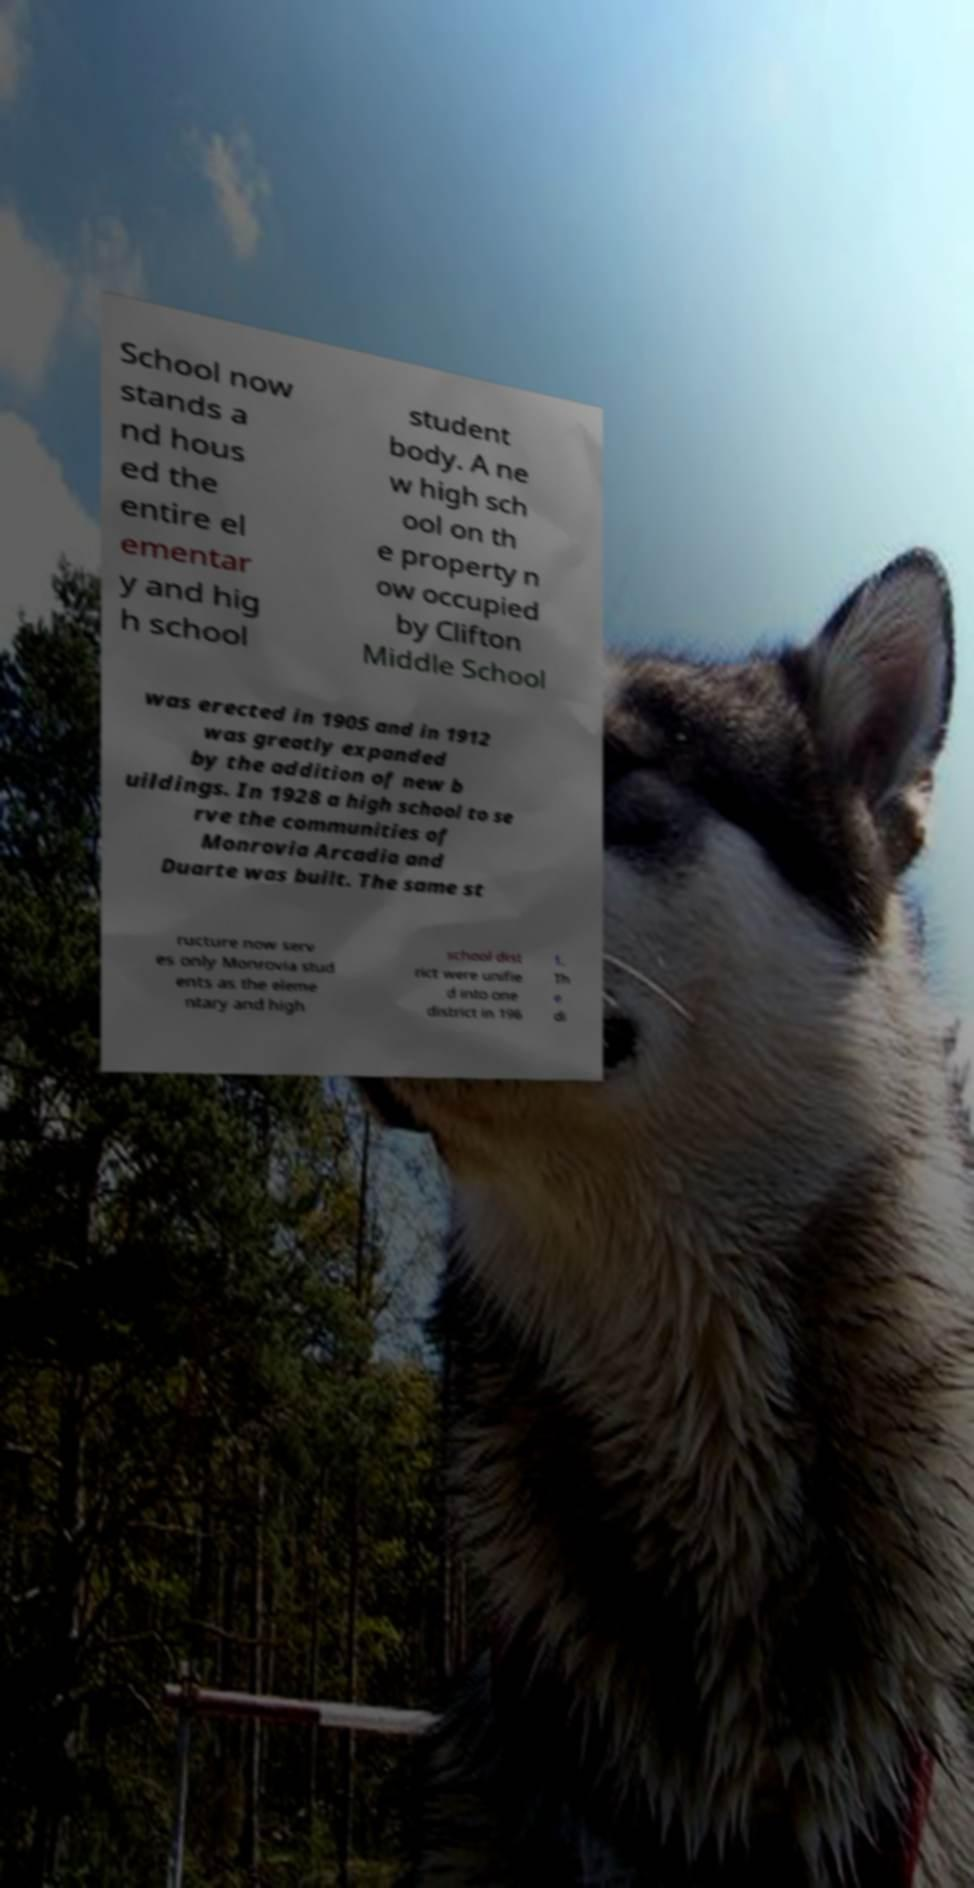Please identify and transcribe the text found in this image. School now stands a nd hous ed the entire el ementar y and hig h school student body. A ne w high sch ool on th e property n ow occupied by Clifton Middle School was erected in 1905 and in 1912 was greatly expanded by the addition of new b uildings. In 1928 a high school to se rve the communities of Monrovia Arcadia and Duarte was built. The same st ructure now serv es only Monrovia stud ents as the eleme ntary and high school dist rict were unifie d into one district in 196 1. Th e di 